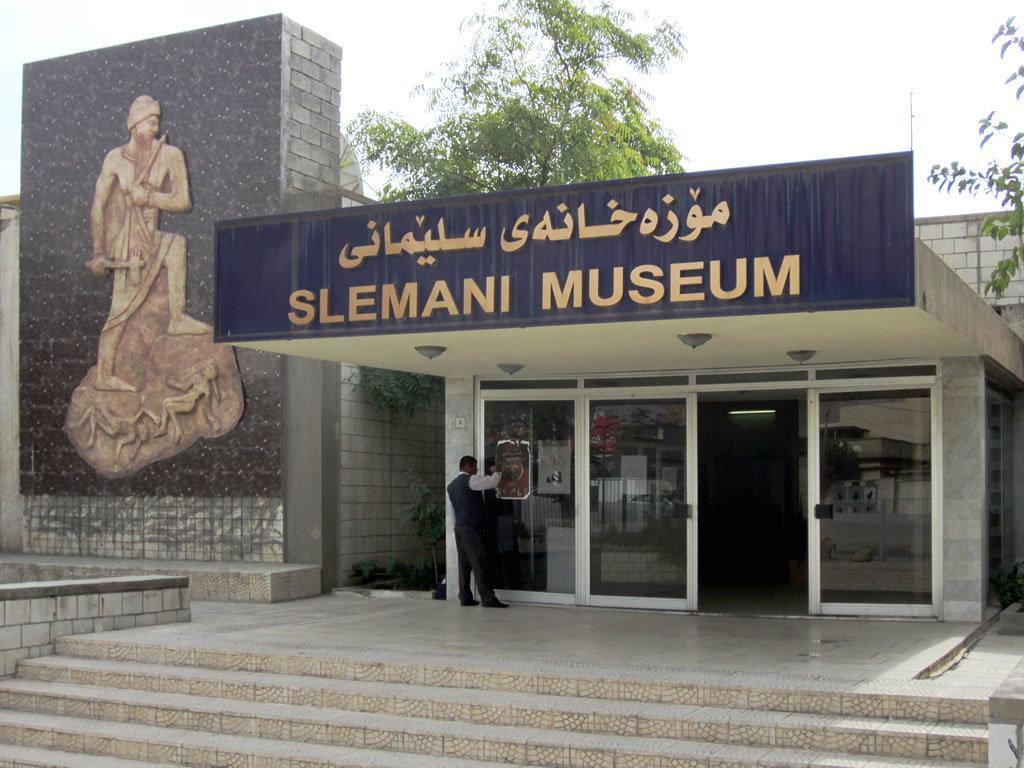What is the main subject of the image? The main subject of the image is Slemani Museum. Can you describe the appearance of the museum? The image shows a front view of the museum, and it has a glass front. What is the person in the image doing? The person is standing on the surface in front of the glass. What can be seen behind the museum? There are trees behind the building. Can you see the bear that the person is smiling at in the image? There is no bear present in the image, and the person's facial expression is not mentioned, so we cannot determine if they are smiling or not. 